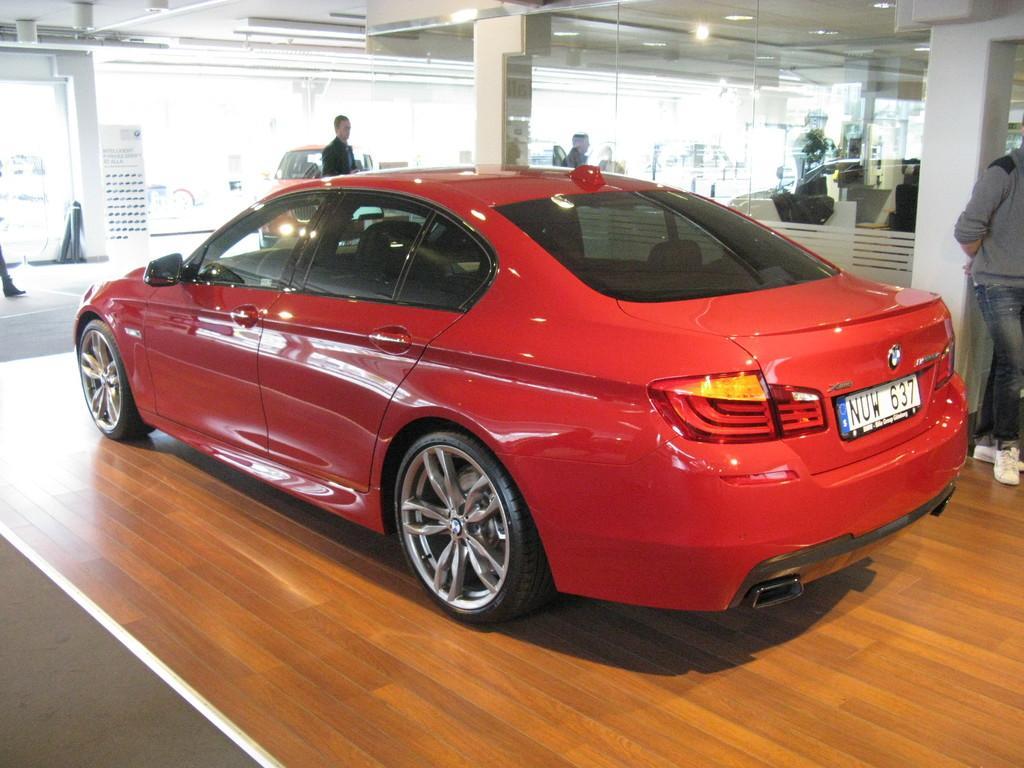How would you summarize this image in a sentence or two? In the center of the image there is a car. On the right side of the image a man is standing at the pillar. In the background there is a glass wall, a man and car. 